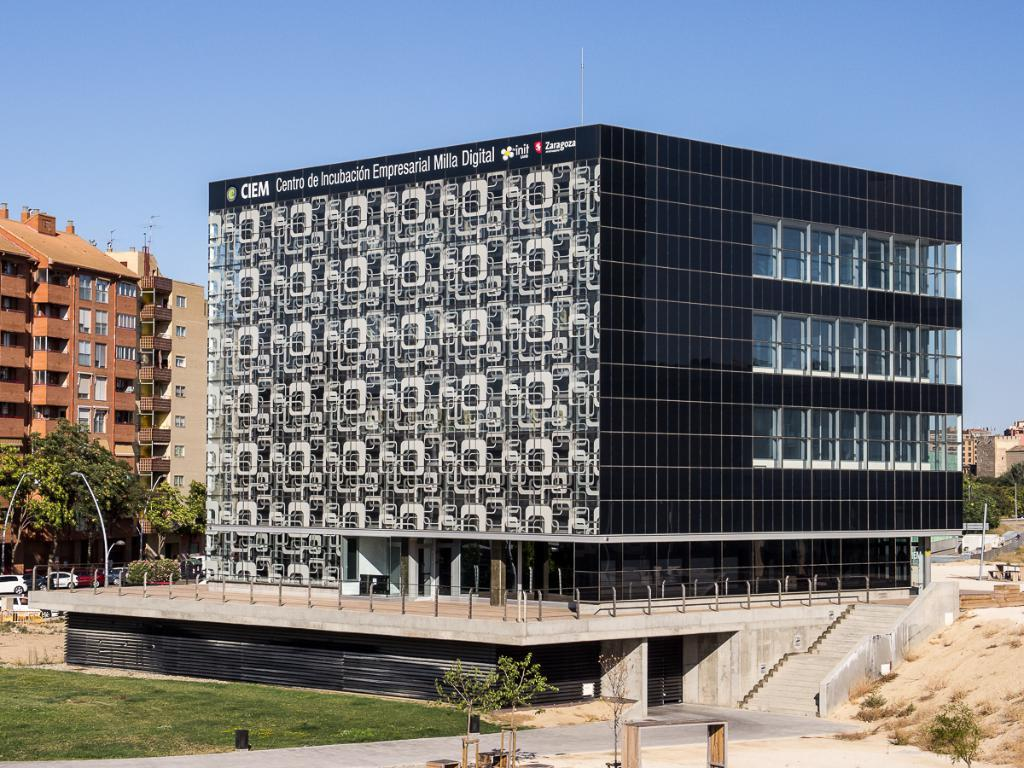What type of structures can be seen in the image? There are buildings in the image. What natural elements are present in the image? There are trees and grass visible in the image. What vehicles can be seen on the left side of the image? Cars are visible on the left side of the image. Where are the stairs located in the image? The stairs are on the right side of the image. What part of the environment is visible in the background of the image? The sky is visible in the background of the image. What type of copper sink can be seen in the image? There is no copper sink present in the image. What time of day is depicted in the image? The time of day cannot be determined from the image, as there are no specific indicators of time. 